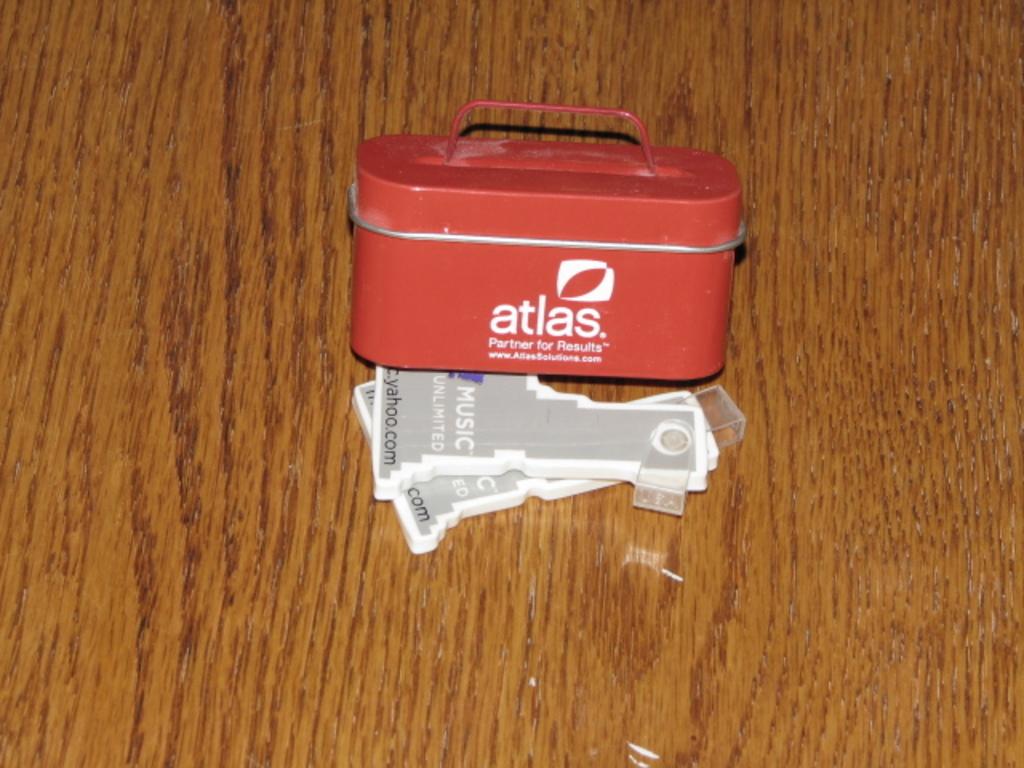What is the website?
Ensure brevity in your answer.  Yahoo.com. 